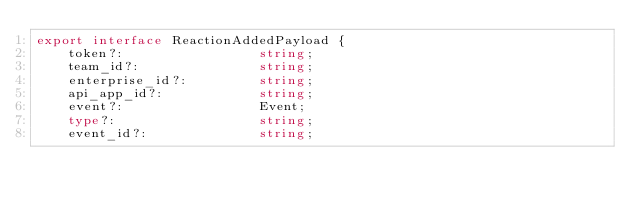Convert code to text. <code><loc_0><loc_0><loc_500><loc_500><_TypeScript_>export interface ReactionAddedPayload {
    token?:                 string;
    team_id?:               string;
    enterprise_id?:         string;
    api_app_id?:            string;
    event?:                 Event;
    type?:                  string;
    event_id?:              string;</code> 